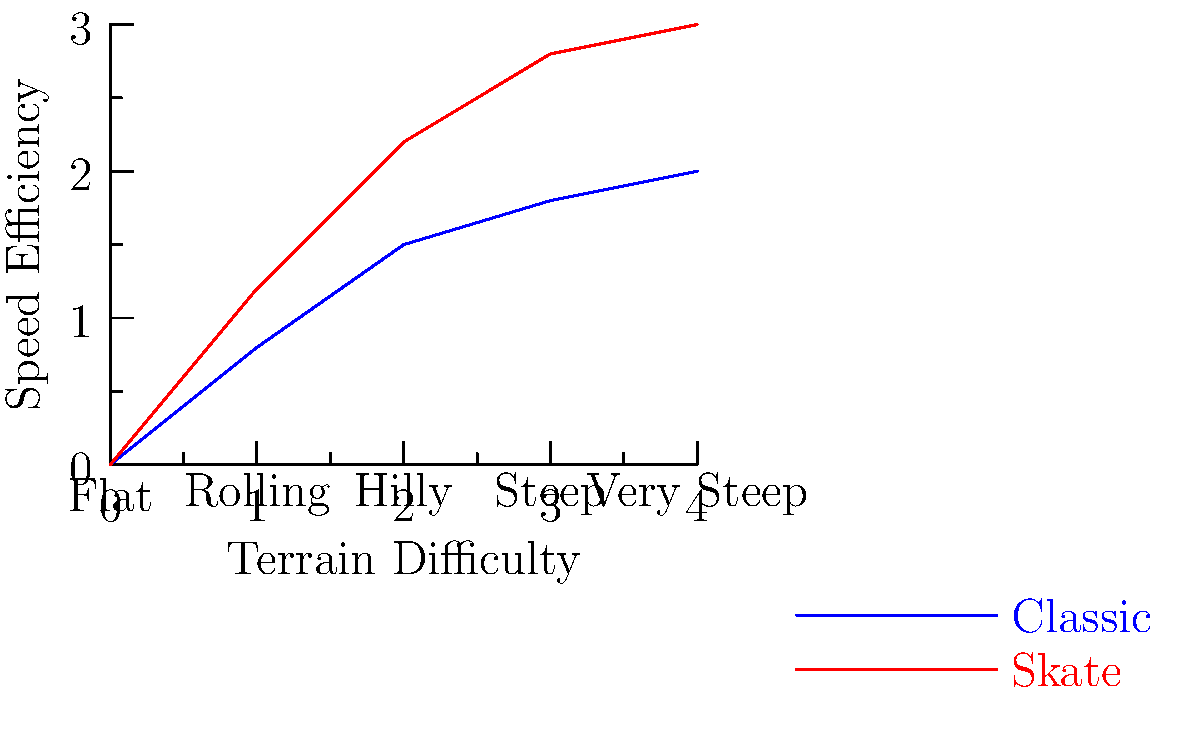Based on the graph illustrating the efficiency of classic and skate skiing techniques across various terrain types, at which terrain difficulty level does the skate technique begin to show a more significant advantage over the classic technique in terms of speed efficiency? To determine when the skate technique shows a more significant advantage, we need to analyze the graph step-by-step:

1. Observe the two lines: blue represents the classic technique, and red represents the skate technique.

2. Compare the vertical distance between the two lines at each terrain difficulty level:
   - Flat (0): Small difference
   - Rolling (1): Slightly larger difference
   - Hilly (2): Noticeably larger difference
   - Steep (3): Even larger difference
   - Very Steep (4): Largest difference

3. The point where the difference becomes more pronounced is at the "Hilly" terrain level (2 on the x-axis).

4. Before this point, the lines are relatively close, indicating similar efficiency.

5. From the "Hilly" terrain onwards, the red line (skate technique) shows a steeper upward trajectory compared to the blue line (classic technique).

6. This increased separation between the lines represents a more significant advantage in speed efficiency for the skate technique.

Therefore, the skate technique begins to show a more significant advantage over the classic technique at the "Hilly" terrain difficulty level.
Answer: Hilly terrain 